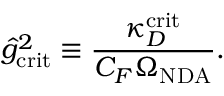Convert formula to latex. <formula><loc_0><loc_0><loc_500><loc_500>\hat { g } _ { c r i t } ^ { 2 } \equiv \frac { \kappa _ { D } ^ { c r i t } } { C _ { F } \Omega _ { N D A } } .</formula> 